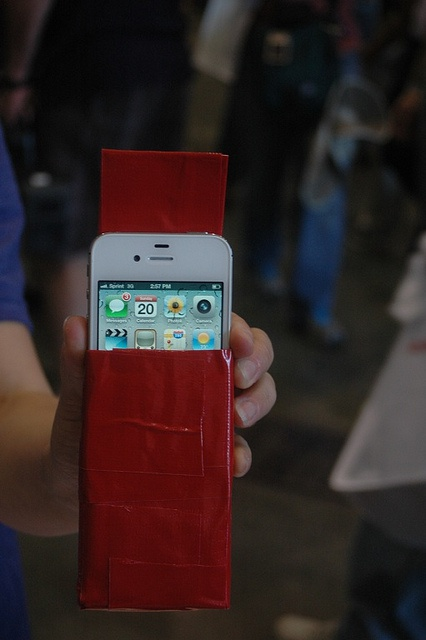Describe the objects in this image and their specific colors. I can see people in black, maroon, gray, and navy tones, cell phone in black, darkgray, teal, and gray tones, and people in black, navy, and darkblue tones in this image. 